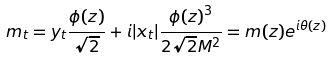<formula> <loc_0><loc_0><loc_500><loc_500>m _ { t } = y _ { t } \frac { \phi ( z ) } { \sqrt { 2 } } + i | x _ { t } | \frac { { \phi ( z ) } ^ { 3 } } { 2 \sqrt { 2 } M ^ { 2 } } = m ( z ) e ^ { i \theta ( z ) }</formula> 